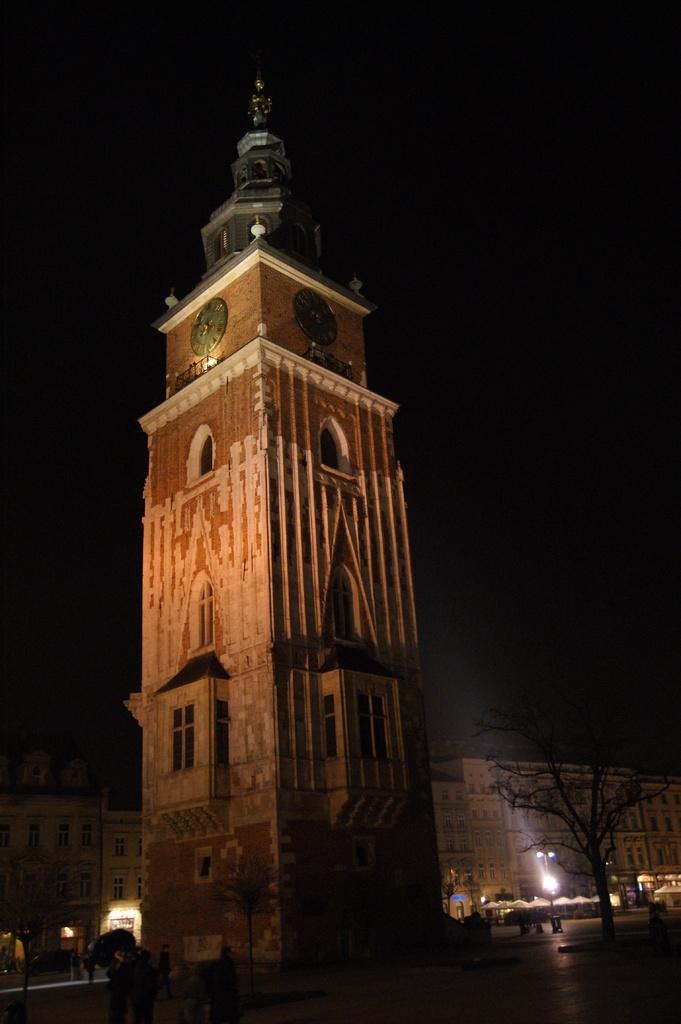What type of structures can be seen in the image? There are buildings in the image. What objects are present that indicate the time? There are clocks in the image. What type of natural elements are visible in the image? There are trees in the image. What type of illumination is present in the image? There are lights in the image. Are there any living beings visible in the image? Yes, there are people in the image. What can be seen in the background of the image? The sky is visible in the background of the image. What type of army is present in the image? There is no army present in the image. What type of office can be seen in the image? There is no office present in the image. 